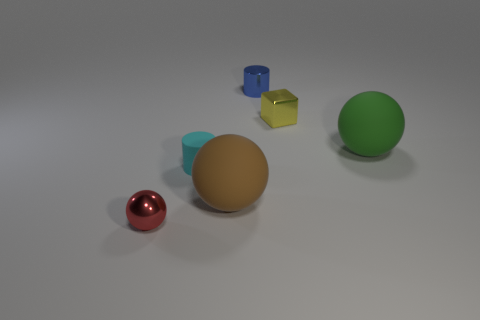Add 3 brown matte balls. How many objects exist? 9 Subtract all cubes. How many objects are left? 5 Add 2 small blue metallic cylinders. How many small blue metallic cylinders are left? 3 Add 1 green matte cylinders. How many green matte cylinders exist? 1 Subtract 0 yellow cylinders. How many objects are left? 6 Subtract all big rubber objects. Subtract all red objects. How many objects are left? 3 